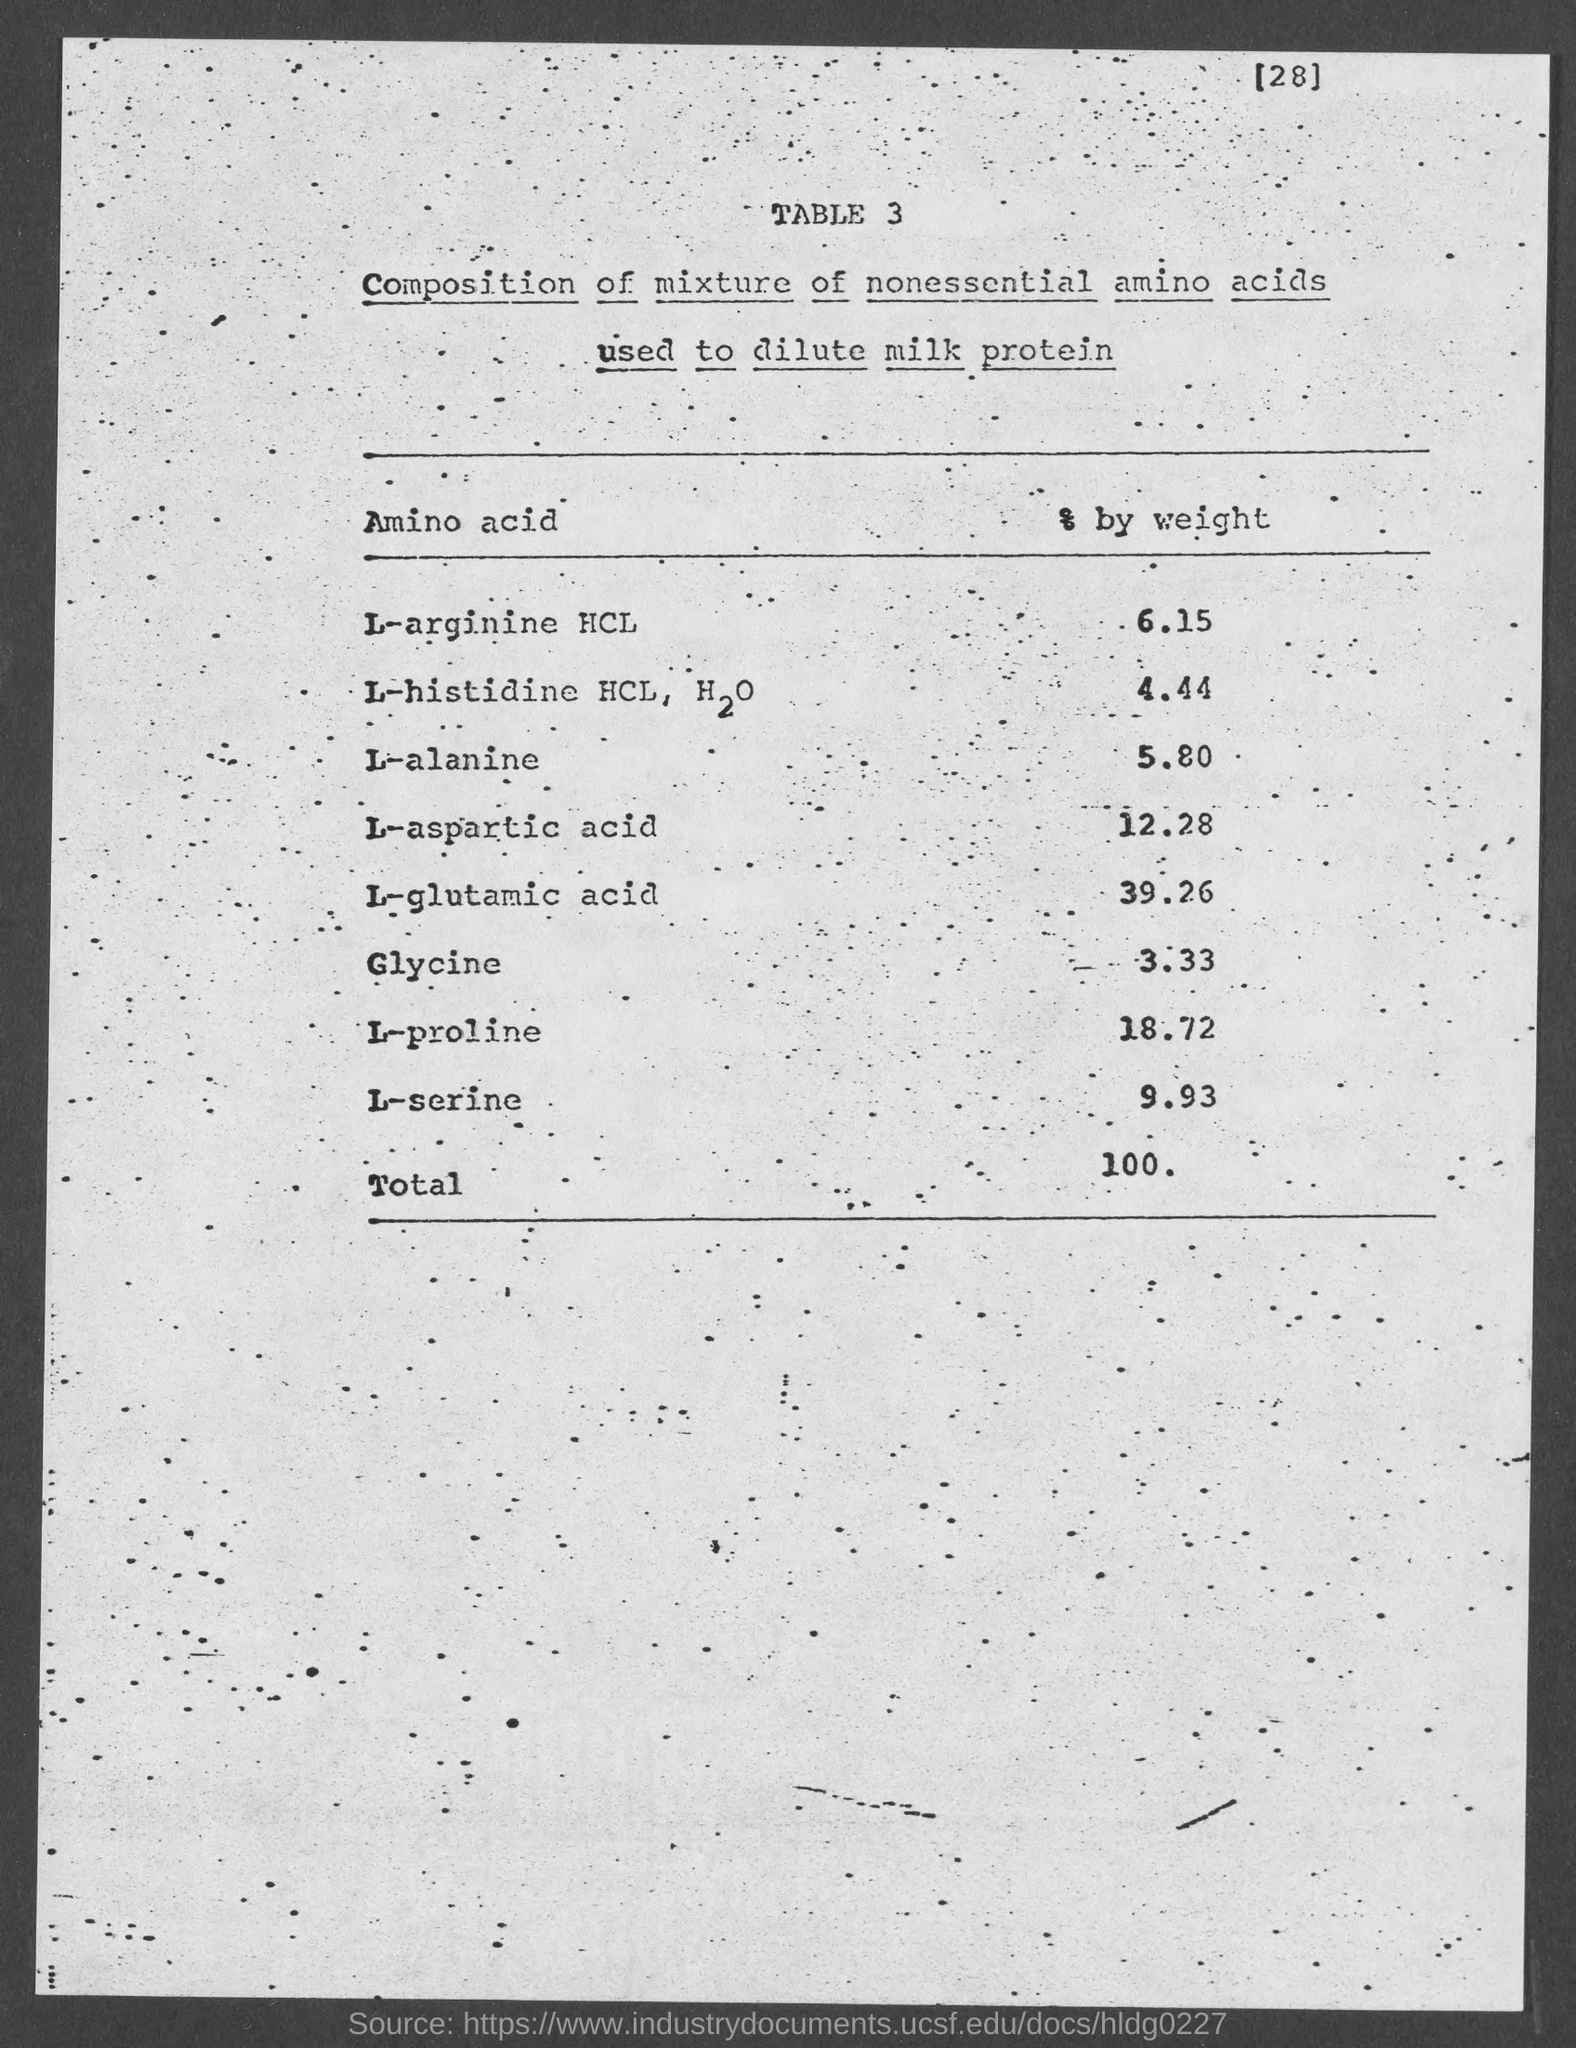Draw attention to some important aspects in this diagram. The total weight is 100...," declared the person. L-glutamic acid is present in a large amount in the mixture. The percentage of glycine in the mixture is approximately 3.33. The second column in the table is titled "Components % by weight. The title of the first column of the table is 'Amino acid'. 